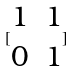Convert formula to latex. <formula><loc_0><loc_0><loc_500><loc_500>[ \begin{matrix} 1 & 1 \\ 0 & 1 \end{matrix} ]</formula> 